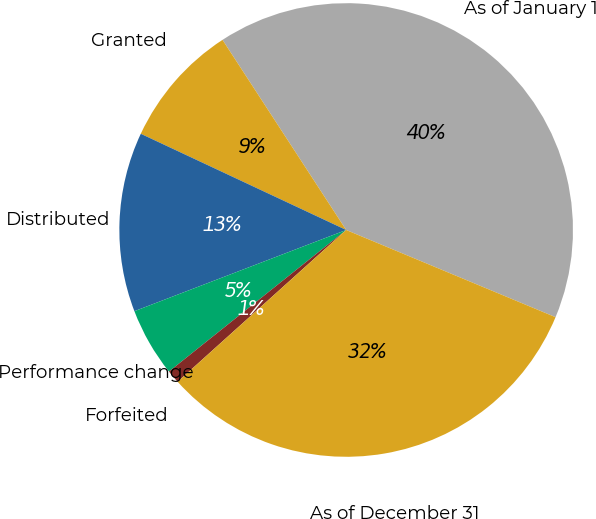<chart> <loc_0><loc_0><loc_500><loc_500><pie_chart><fcel>As of January 1<fcel>Granted<fcel>Distributed<fcel>Performance change<fcel>Forfeited<fcel>As of December 31<nl><fcel>40.46%<fcel>8.85%<fcel>12.8%<fcel>4.9%<fcel>0.94%<fcel>32.05%<nl></chart> 